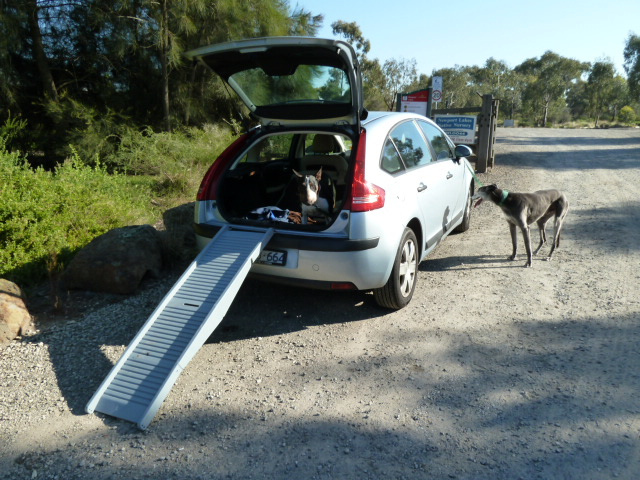What is the dog outside the car likely thinking? The dog outside the car is probably curious about the ramp and might be contemplating climbing into the car to join the other dog inside. It could also be assessing the situation to ensure it's safe and secure. 